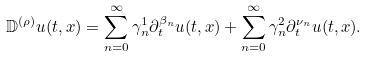Convert formula to latex. <formula><loc_0><loc_0><loc_500><loc_500>\mathbb { D } ^ { ( \rho ) } u ( t , x ) = \sum _ { n = 0 } ^ { \infty } \gamma ^ { 1 } _ { n } \partial ^ { \beta _ { n } } _ { t } u ( t , x ) + \sum _ { n = 0 } ^ { \infty } \gamma ^ { 2 } _ { n } \partial ^ { \nu _ { n } } _ { t } u ( t , x ) .</formula> 